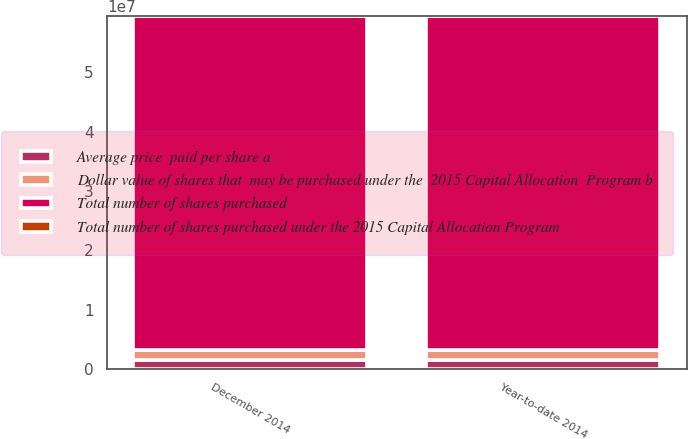<chart> <loc_0><loc_0><loc_500><loc_500><stacked_bar_chart><ecel><fcel>December 2014<fcel>Year-to-date 2014<nl><fcel>Dollar value of shares that  may be purchased under the  2015 Capital Allocation  Program b<fcel>1.62436e+06<fcel>1.62436e+06<nl><fcel>Total number of shares purchased under the 2015 Capital Allocation Program<fcel>26.95<fcel>26.95<nl><fcel>Average price  paid per share a<fcel>1.62436e+06<fcel>1.62436e+06<nl><fcel>Total number of shares purchased<fcel>5.6207e+07<fcel>5.6207e+07<nl></chart> 